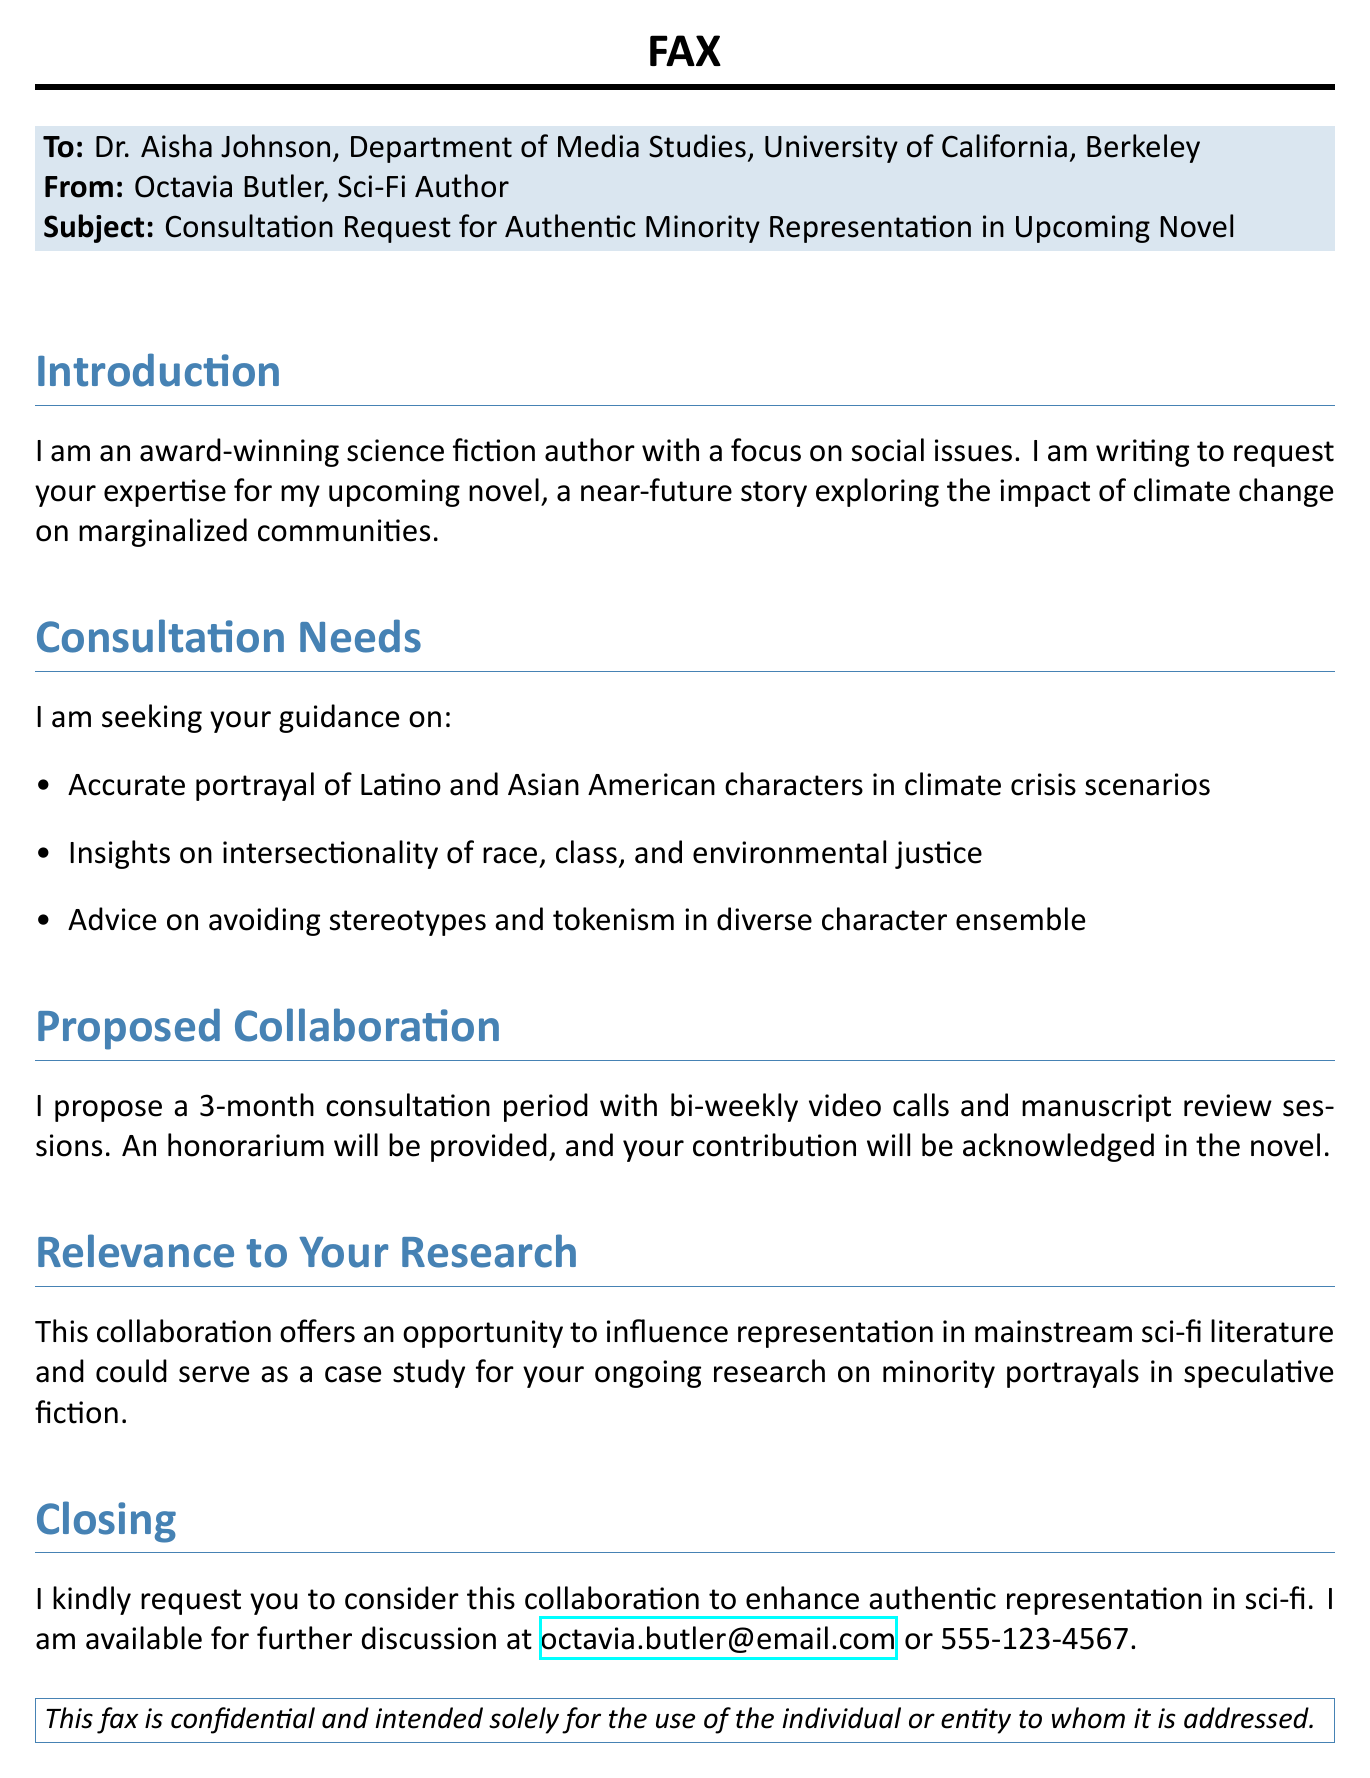What is the name of the sender? The sender is identified as Octavia Butler in the document.
Answer: Octavia Butler What is the subject of the fax? The subject clearly states the purpose of the correspondence regarding representation in literature.
Answer: Consultation Request for Authentic Minority Representation in Upcoming Novel How long is the proposed consultation period? The document explicitly mentions the duration for the collaboration.
Answer: 3 months Which two minority groups are specifically mentioned for character portrayal? The groups highlighted in the consultation needs section are important for the writer's focus.
Answer: Latino and Asian American What type of sessions will be conducted during the consultation? The document specifies the format of interaction proposed for the consultation.
Answer: Video calls and manuscript review sessions What is the importance of this collaboration according to the sender? The sender emphasizes a significant aspect of the collaboration concerning literature and research.
Answer: Influence representation in mainstream sci-fi literature What will the contributor receive for their involvement? The document states a reward for participation in the consultation effort.
Answer: An honorarium What email is provided for further discussion? The document includes a contact method for further communication.
Answer: octavia.butler@email.com 